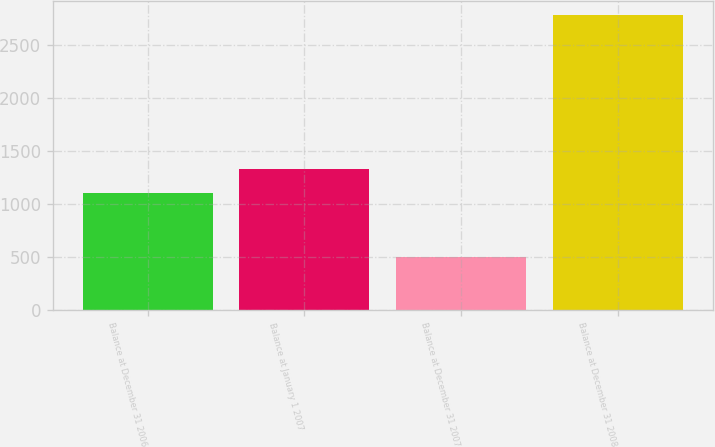Convert chart to OTSL. <chart><loc_0><loc_0><loc_500><loc_500><bar_chart><fcel>Balance at December 31 2006<fcel>Balance at January 1 2007<fcel>Balance at December 31 2007<fcel>Balance at December 31 2008<nl><fcel>1102<fcel>1330.3<fcel>503<fcel>2786<nl></chart> 